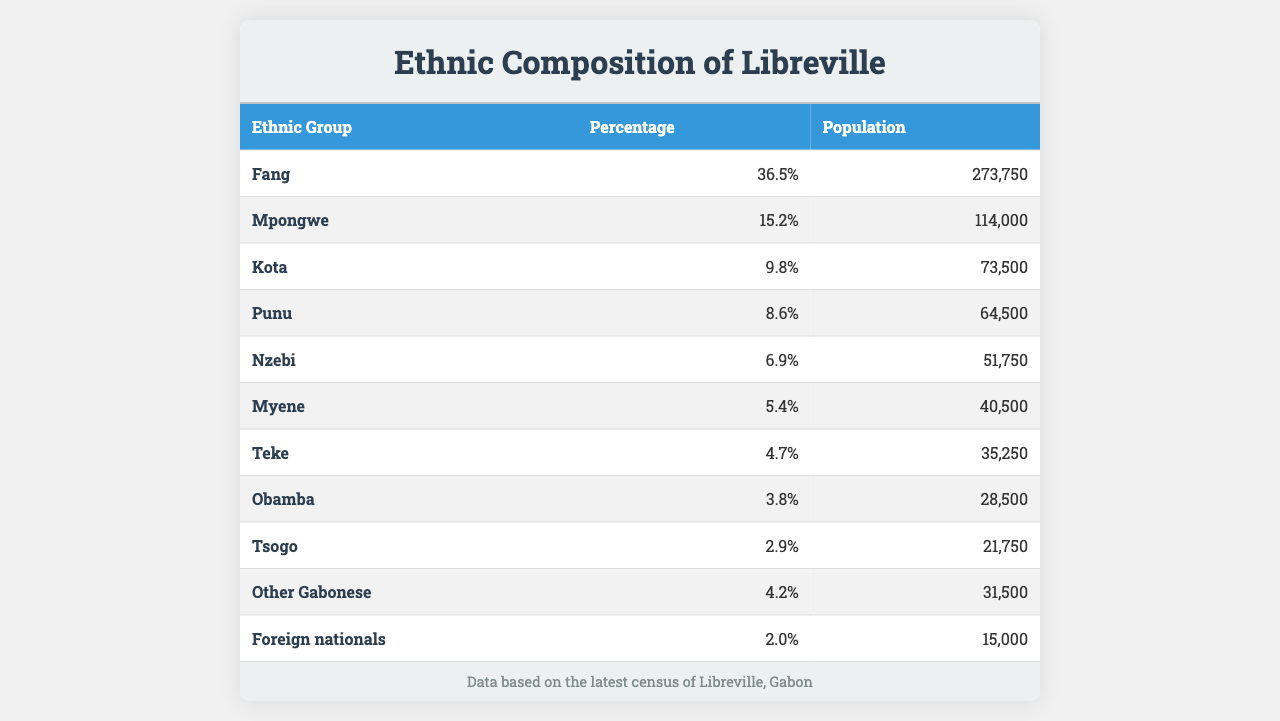What is the percentage of the Fang ethnic group in Libreville? The table states that the Fang group constitutes 36.5% of the population in Libreville.
Answer: 36.5% How many people belong to the Mpongwe ethnic group? According to the table, the Mpongwe group has a population of 114,000 in Libreville.
Answer: 114,000 What is the total percentage of the first three largest ethnic groups combined? Adding the percentages of Fang (36.5%), Mpongwe (15.2%), and Kota (9.8%) results in 36.5 + 15.2 + 9.8 = 61.5%.
Answer: 61.5% Is the percentage of Foreign nationals greater than 3.0%? The table shows that Foreign nationals account for 2.0% of the population, which is less than 3.0%.
Answer: No How does the population of the Nzebi ethnic group compare to that of the Myene ethnic group? The Nzebi group has a population of 51,750, whereas the Myene group has a population of 40,500. Thus, Nzebi has a larger population.
Answer: Nzebi has a larger population What is the combined population of the Teke and Obamba ethnic groups? The Teke group has a population of 35,250 and the Obamba group has a population of 28,500. Adding these gives 35,250 + 28,500 = 63,750.
Answer: 63,750 Which ethnic group has the smallest population? The table shows that the Tsogo ethnic group has a population of 21,750, making it the smallest group listed.
Answer: Tsogo What percentage of the population do Other Gabonese and Foreign nationals represent combined? The Other Gabonese group is 4.2% and the Foreign nationals group is 2.0%. Combined, they represent 4.2 + 2.0 = 6.2%.
Answer: 6.2% What is the average population of the top 5 ethnic groups in Libreville? The populations of the top 5 groups are Fang (273,750), Mpongwe (114,000), Kota (73,500), Punu (64,500), and Nzebi (51,750). Summing these yields 273,750 + 114,000 + 73,500 + 64,500 + 51,750 = 577,500. Dividing by 5 gives an average of 577,500 / 5 = 115,500.
Answer: 115,500 Which ethnic group constitutes more than 5% of Libreville's population? The groups Fang (36.5%), Mpongwe (15.2%), and Kota (9.8%) all have percentages above 5%, while Myene (5.4%) is just below.
Answer: Fang, Mpongwe, Kota What is the difference in population between the Kota and Punu ethnic groups? The Kota group has a population of 73,500 and the Punu group has 64,500. The difference is 73,500 - 64,500 = 9,000.
Answer: 9,000 